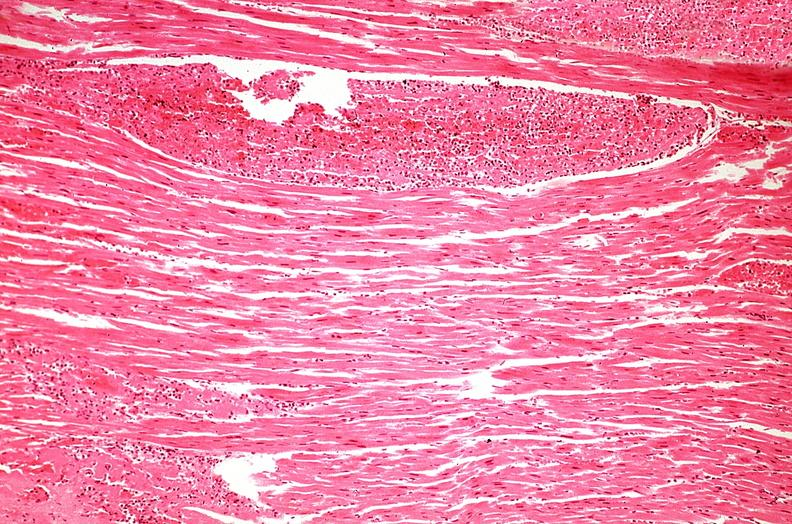does chest and abdomen slide show heart, myocardial infarction, wavey fiber change, necrtosis, hemorrhage, and dissection?
Answer the question using a single word or phrase. No 